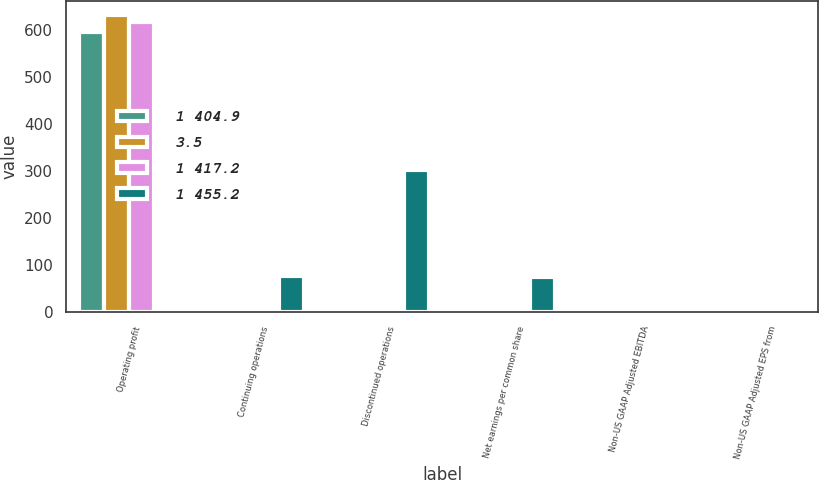<chart> <loc_0><loc_0><loc_500><loc_500><stacked_bar_chart><ecel><fcel>Operating profit<fcel>Continuing operations<fcel>Discontinued operations<fcel>Net earnings per common share<fcel>Non-US GAAP Adjusted EBITDA<fcel>Non-US GAAP Adjusted EPS from<nl><fcel>1 404.9<fcel>596<fcel>0.34<fcel>3.99<fcel>4.29<fcel>3<fcel>1.81<nl><fcel>3.5<fcel>631.4<fcel>1.5<fcel>0.99<fcel>2.46<fcel>3<fcel>1.7<nl><fcel>1 417.2<fcel>617.4<fcel>0.78<fcel>0.85<fcel>1.62<fcel>3<fcel>1.84<nl><fcel>1 455.2<fcel>5.6<fcel>77.3<fcel>303<fcel>74.4<fcel>3<fcel>6.5<nl></chart> 